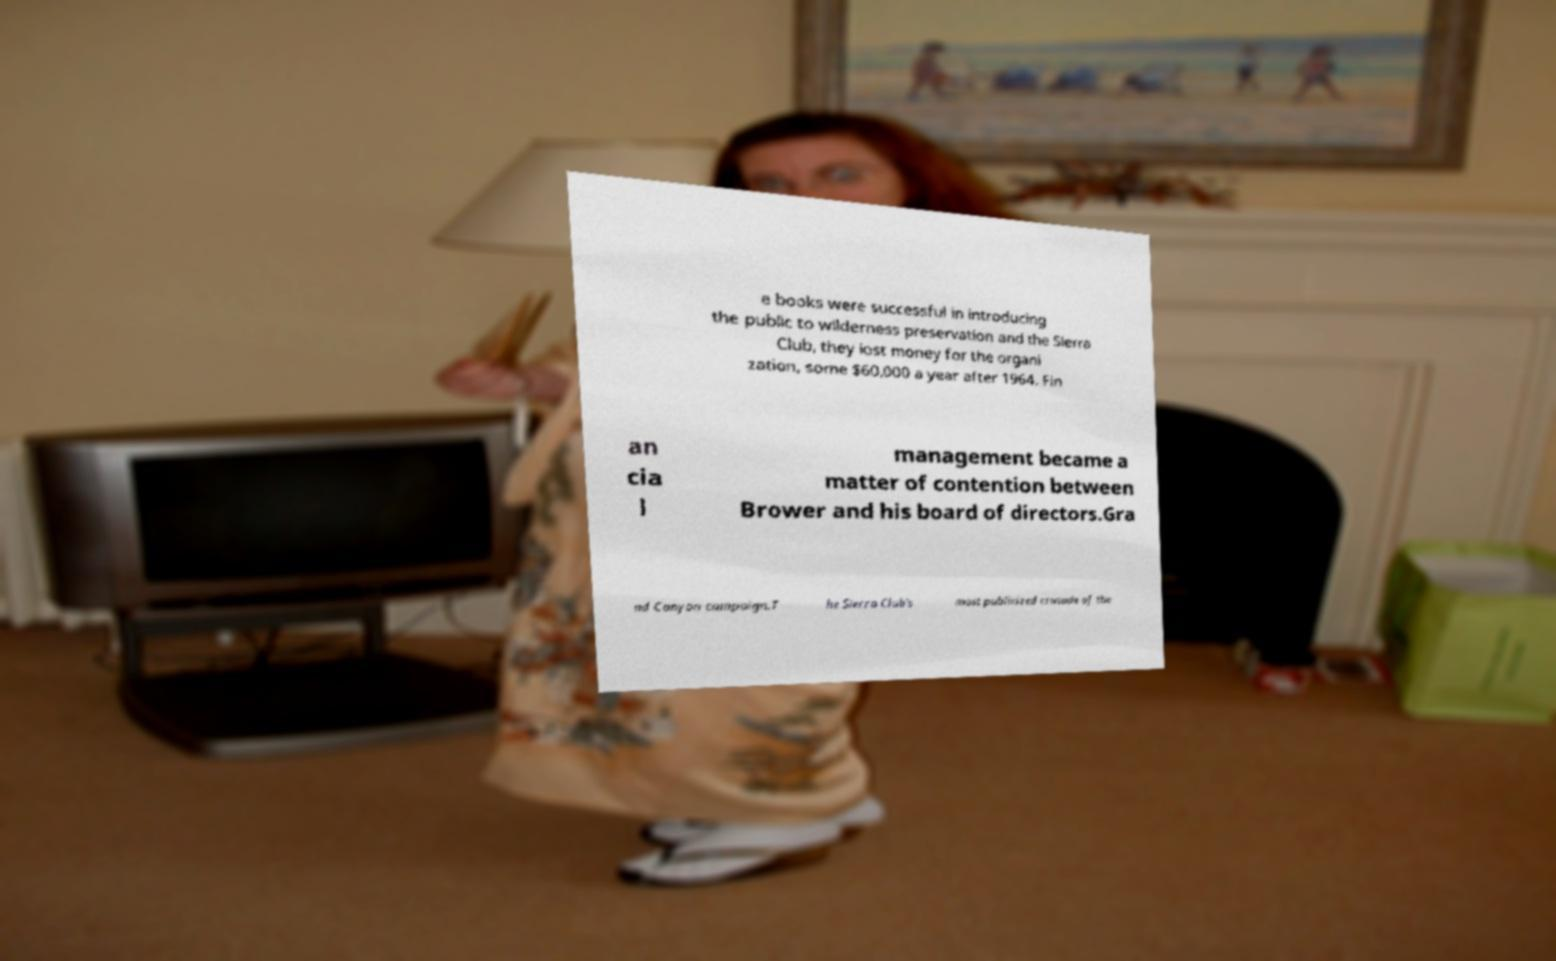Can you accurately transcribe the text from the provided image for me? e books were successful in introducing the public to wilderness preservation and the Sierra Club, they lost money for the organi zation, some $60,000 a year after 1964. Fin an cia l management became a matter of contention between Brower and his board of directors.Gra nd Canyon campaign.T he Sierra Club's most publicized crusade of the 